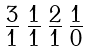<formula> <loc_0><loc_0><loc_500><loc_500>\begin{smallmatrix} 3 & 1 & 2 & 1 \\ \overline { 1 } & \overline { 1 } & \overline { 1 } & \overline { 0 } \end{smallmatrix}</formula> 